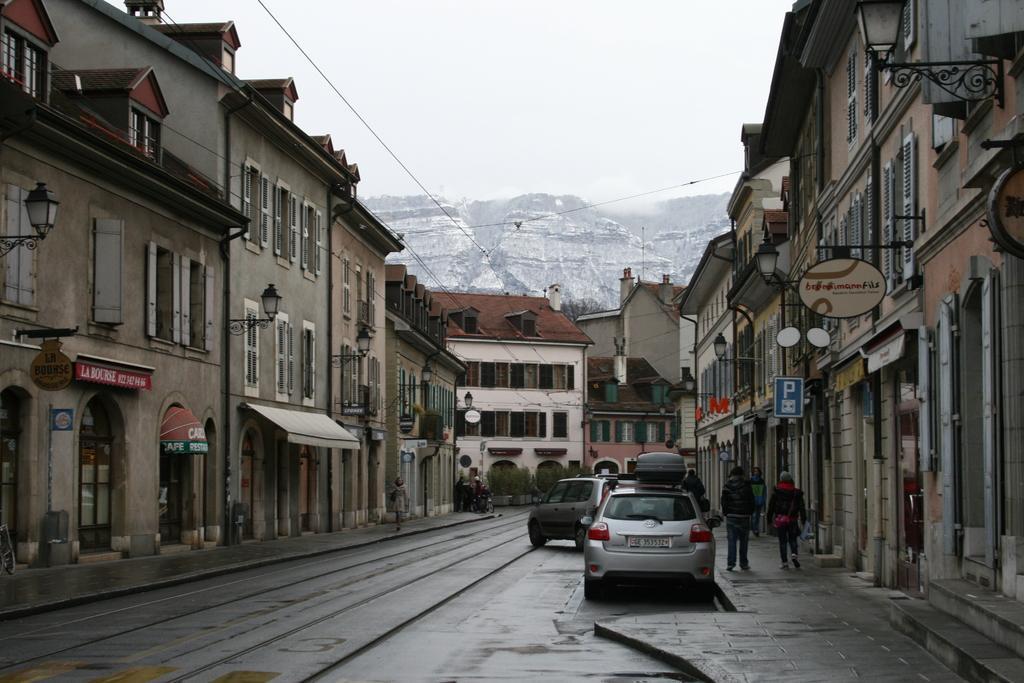How would you summarize this image in a sentence or two? In the center of the image there is a road on which there are vehicles. In the background of the image there are houses, mountains. To the both sides of the image there are buildings. 